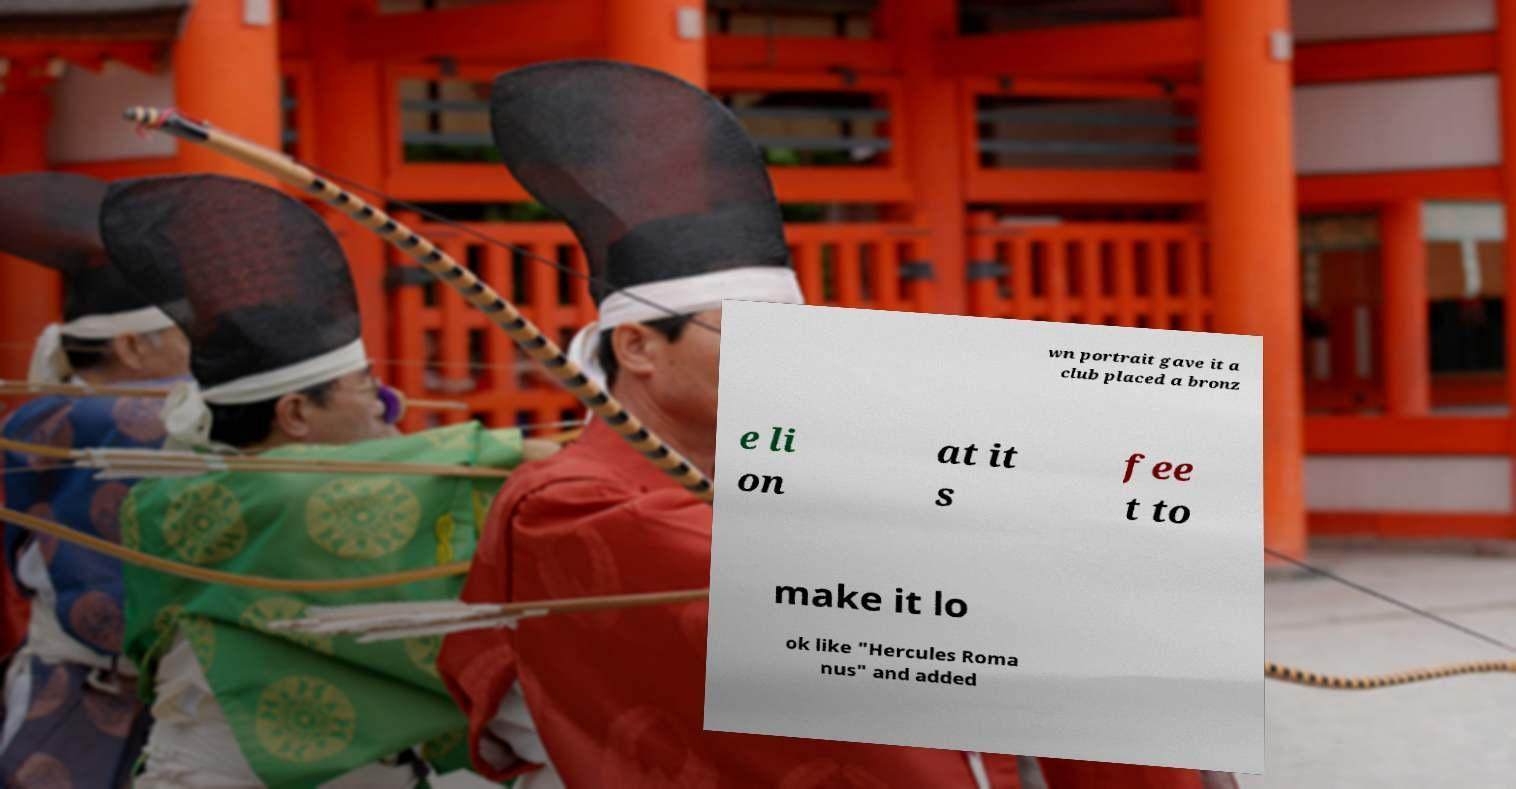Could you extract and type out the text from this image? wn portrait gave it a club placed a bronz e li on at it s fee t to make it lo ok like "Hercules Roma nus" and added 